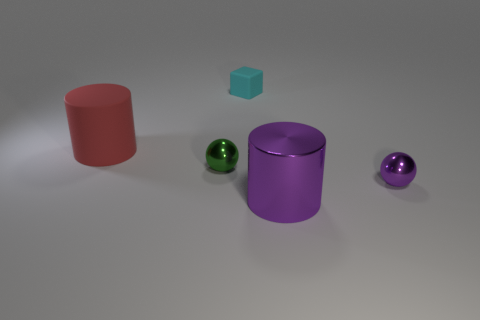There is another object that is the same shape as the large red thing; what is its size?
Offer a terse response. Large. Do the big red cylinder and the tiny green thing have the same material?
Keep it short and to the point. No. What number of objects are matte objects to the left of the tiny block or cylinders behind the shiny cylinder?
Offer a very short reply. 1. There is another big object that is the same shape as the red rubber thing; what color is it?
Provide a short and direct response. Purple. What number of large metal cylinders are the same color as the small matte cube?
Your answer should be compact. 0. Is the color of the block the same as the big metal cylinder?
Offer a terse response. No. What number of things are big cylinders on the left side of the tiny cyan rubber object or big brown matte cylinders?
Keep it short and to the point. 1. What color is the small ball behind the purple metal thing that is behind the large cylinder to the right of the small cyan thing?
Keep it short and to the point. Green. There is another tiny sphere that is the same material as the green ball; what color is it?
Keep it short and to the point. Purple. What number of big green cubes are the same material as the tiny cyan block?
Offer a very short reply. 0. 